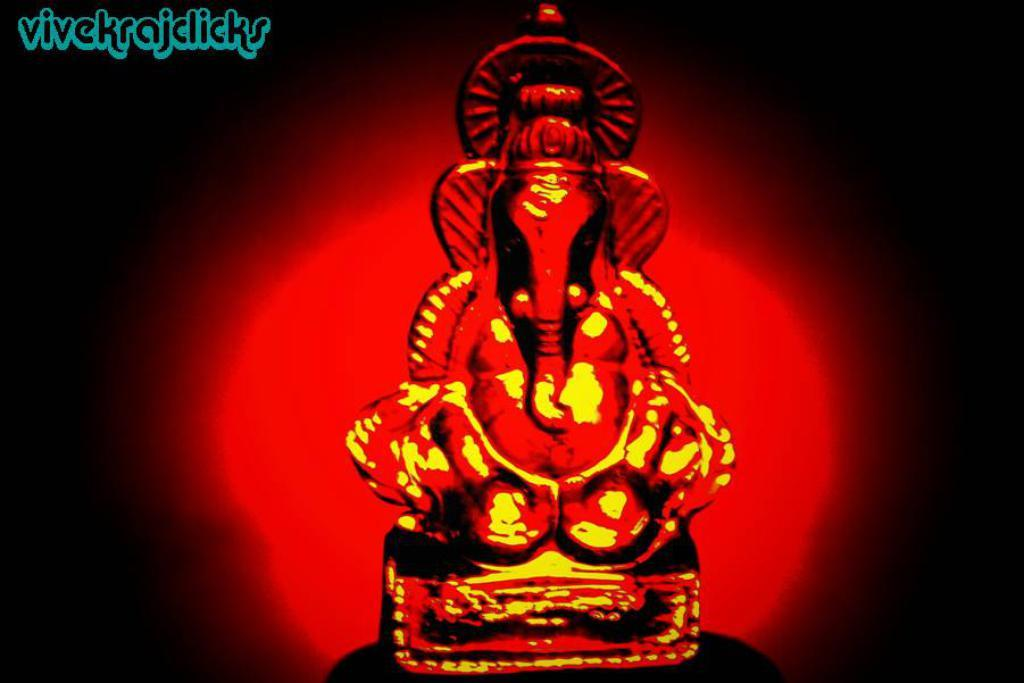What is the main subject of the image? There is a red color Ganesha in the image. Can you describe any text present in the image? There is text in the top left corner of the image. What type of furniture can be seen in the scene depicted in the image? There is no scene depicted in the image, as it only features a red color Ganesha and text in the top left corner. 